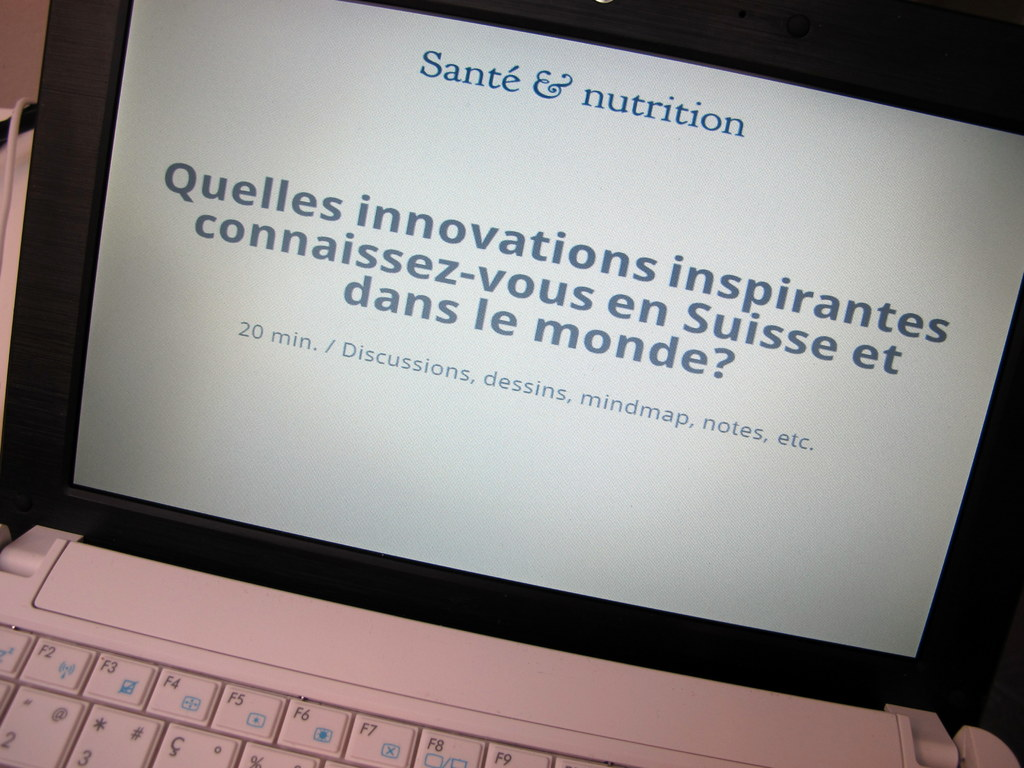What's happening in the scene? The image captures a laptop screen displaying a slide from a presentation in French focused on 'Health & Nutrition'. The slide, titled 'Santé & nutrition', queries attendees about inspiring health and nutrition innovations, both in Switzerland and globally. It encourages an interactive session lasting 20 minutes where participants can engage through discussions, drawings, mind maps, and notes, aiming to foster a collaborative and creative environment. 